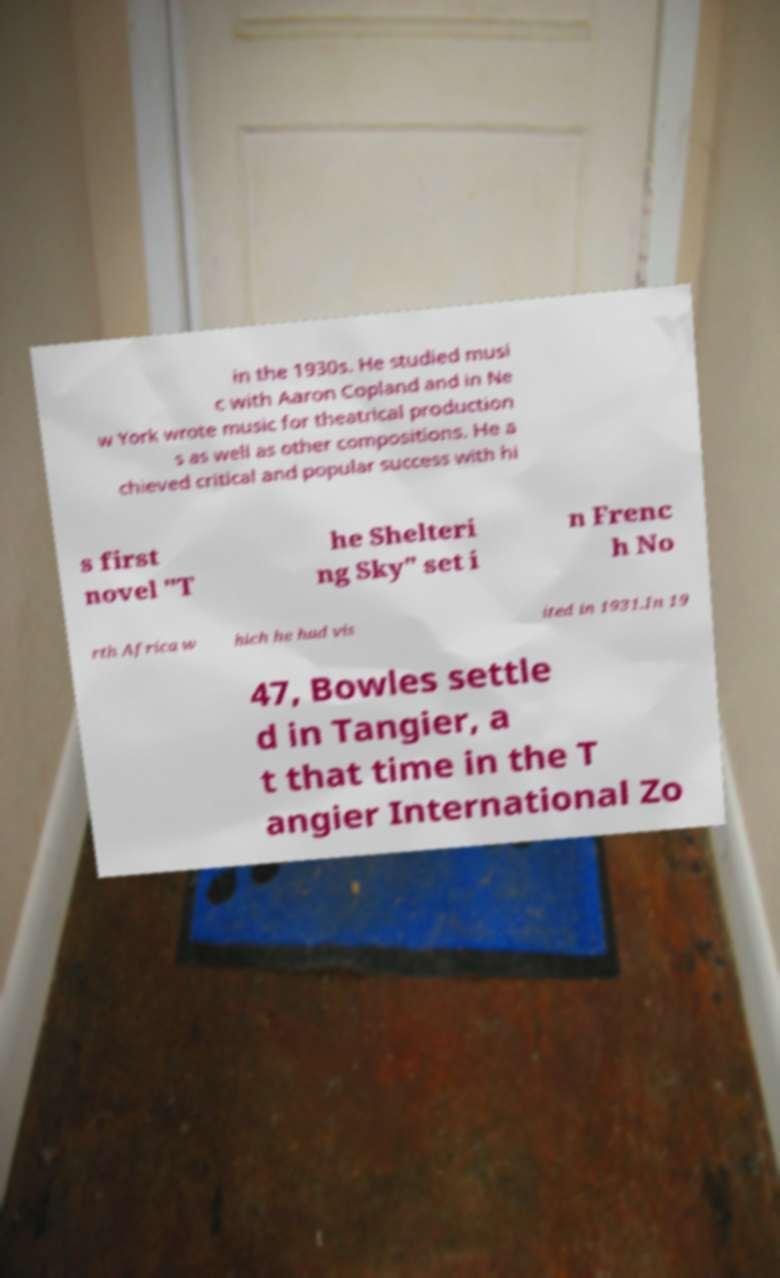Can you read and provide the text displayed in the image?This photo seems to have some interesting text. Can you extract and type it out for me? in the 1930s. He studied musi c with Aaron Copland and in Ne w York wrote music for theatrical production s as well as other compositions. He a chieved critical and popular success with hi s first novel "T he Shelteri ng Sky" set i n Frenc h No rth Africa w hich he had vis ited in 1931.In 19 47, Bowles settle d in Tangier, a t that time in the T angier International Zo 